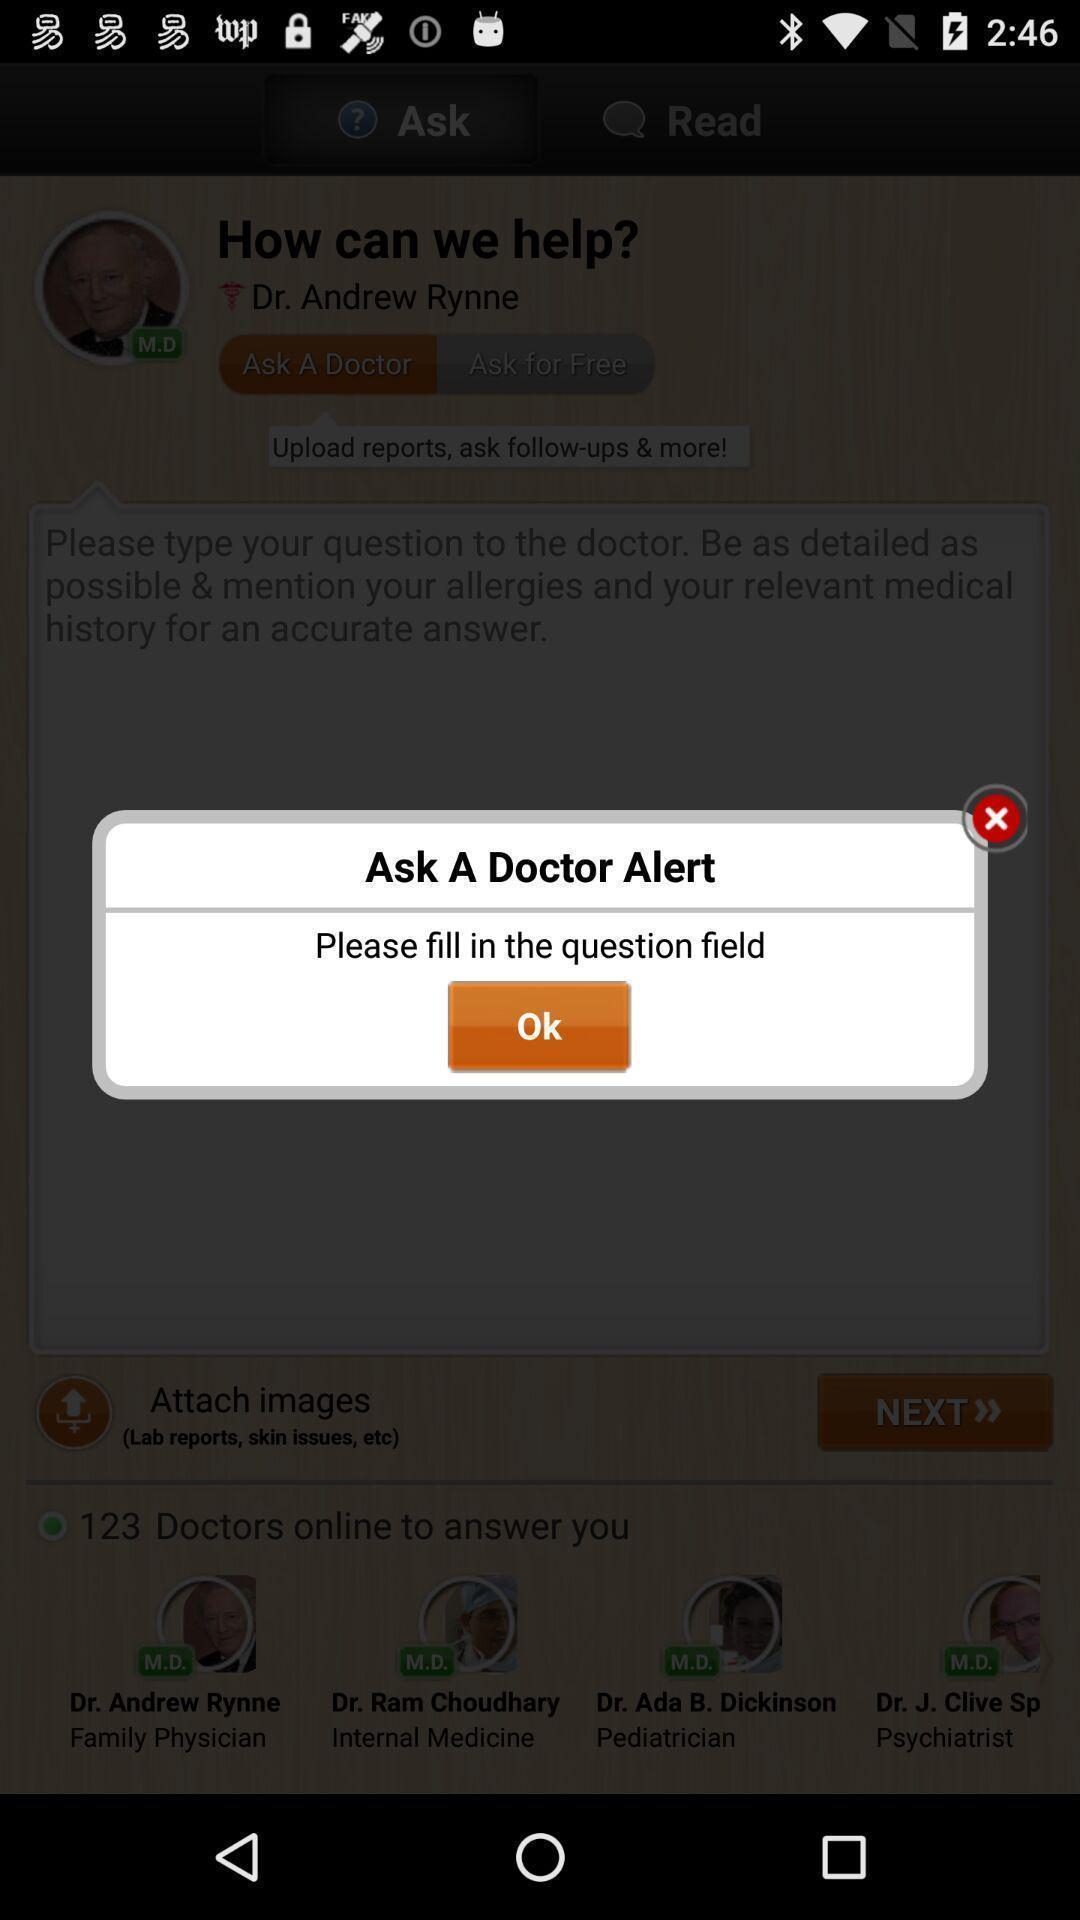What is the overall content of this screenshot? Pop-up showing the doctor alert. 